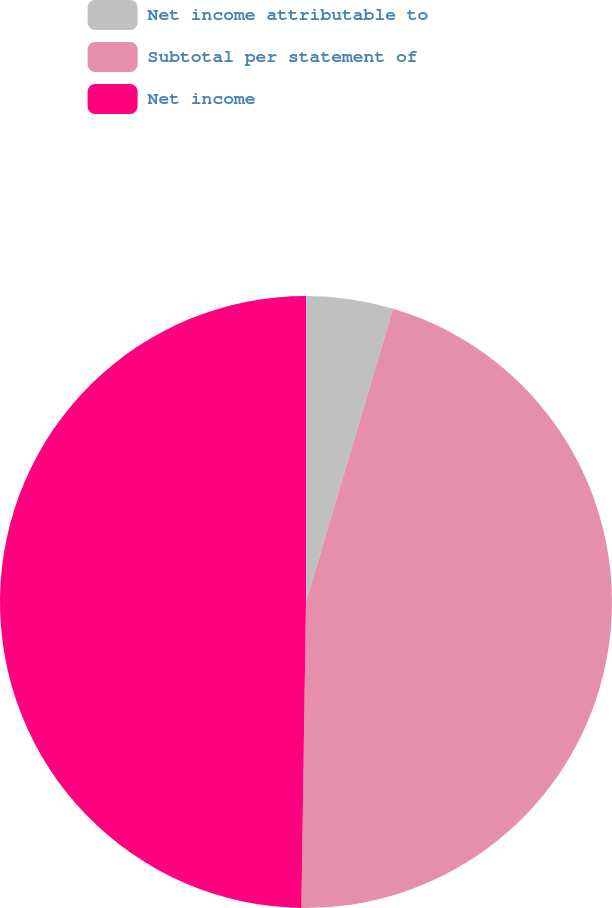Convert chart. <chart><loc_0><loc_0><loc_500><loc_500><pie_chart><fcel>Net income attributable to<fcel>Subtotal per statement of<fcel>Net income<nl><fcel>4.59%<fcel>45.65%<fcel>49.76%<nl></chart> 